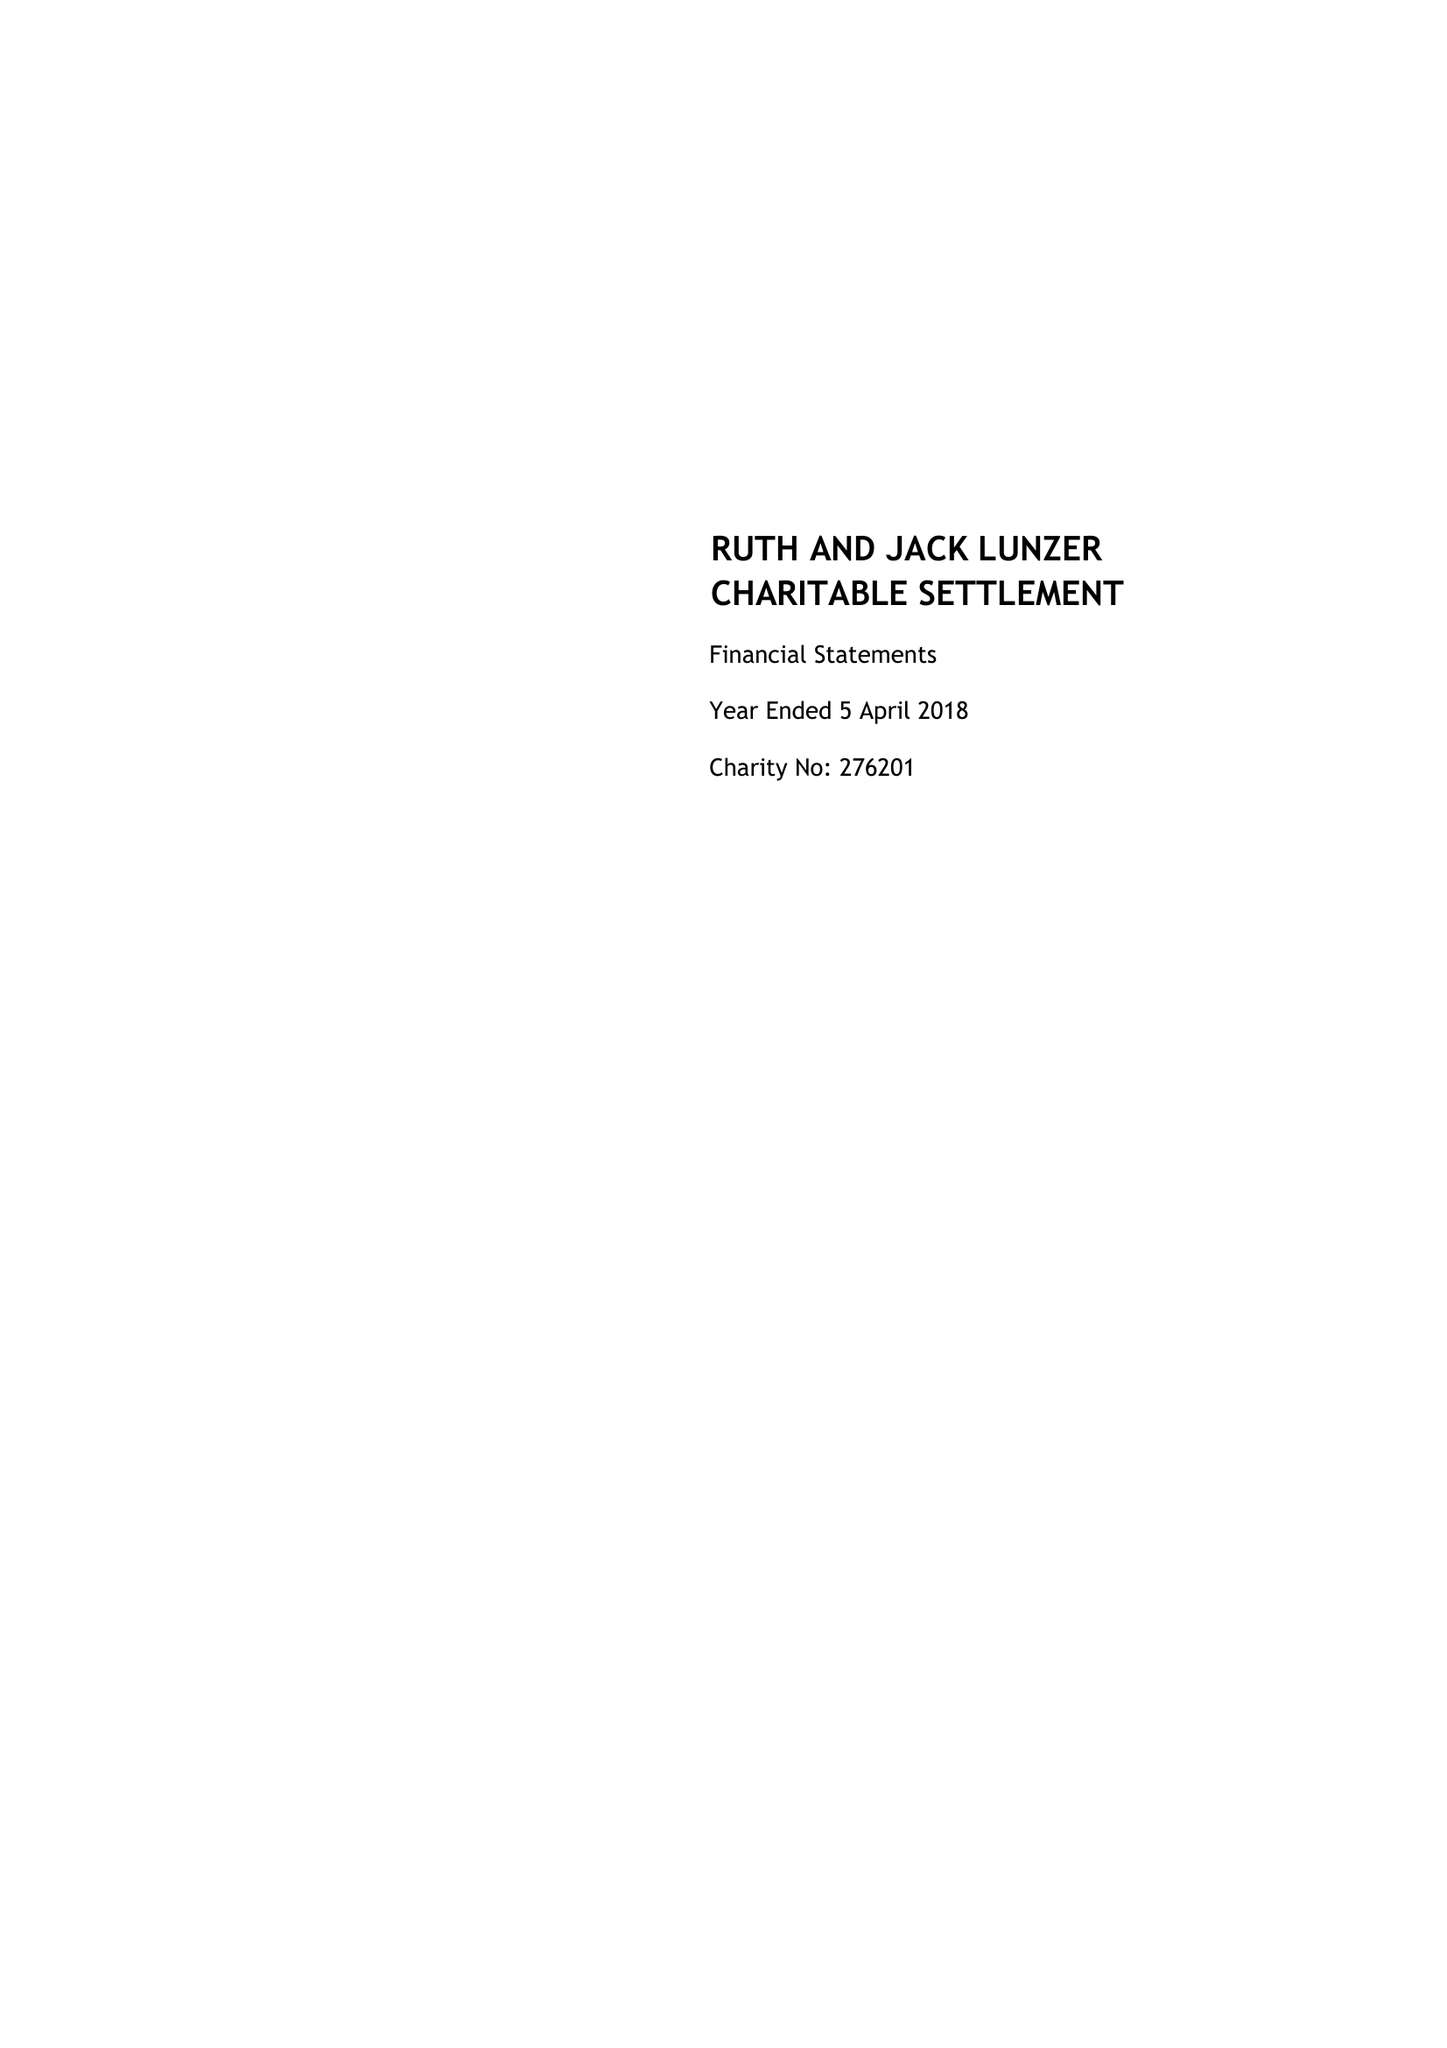What is the value for the income_annually_in_british_pounds?
Answer the question using a single word or phrase. 37750.00 